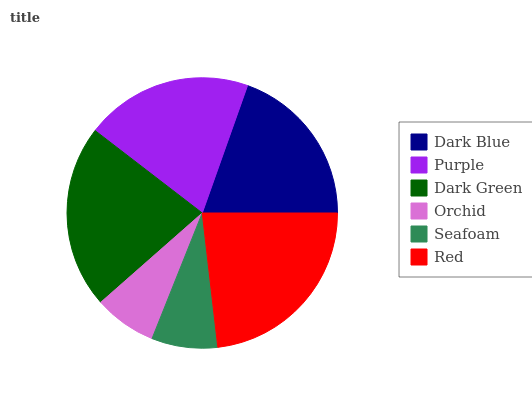Is Orchid the minimum?
Answer yes or no. Yes. Is Red the maximum?
Answer yes or no. Yes. Is Purple the minimum?
Answer yes or no. No. Is Purple the maximum?
Answer yes or no. No. Is Purple greater than Dark Blue?
Answer yes or no. Yes. Is Dark Blue less than Purple?
Answer yes or no. Yes. Is Dark Blue greater than Purple?
Answer yes or no. No. Is Purple less than Dark Blue?
Answer yes or no. No. Is Purple the high median?
Answer yes or no. Yes. Is Dark Blue the low median?
Answer yes or no. Yes. Is Orchid the high median?
Answer yes or no. No. Is Dark Green the low median?
Answer yes or no. No. 